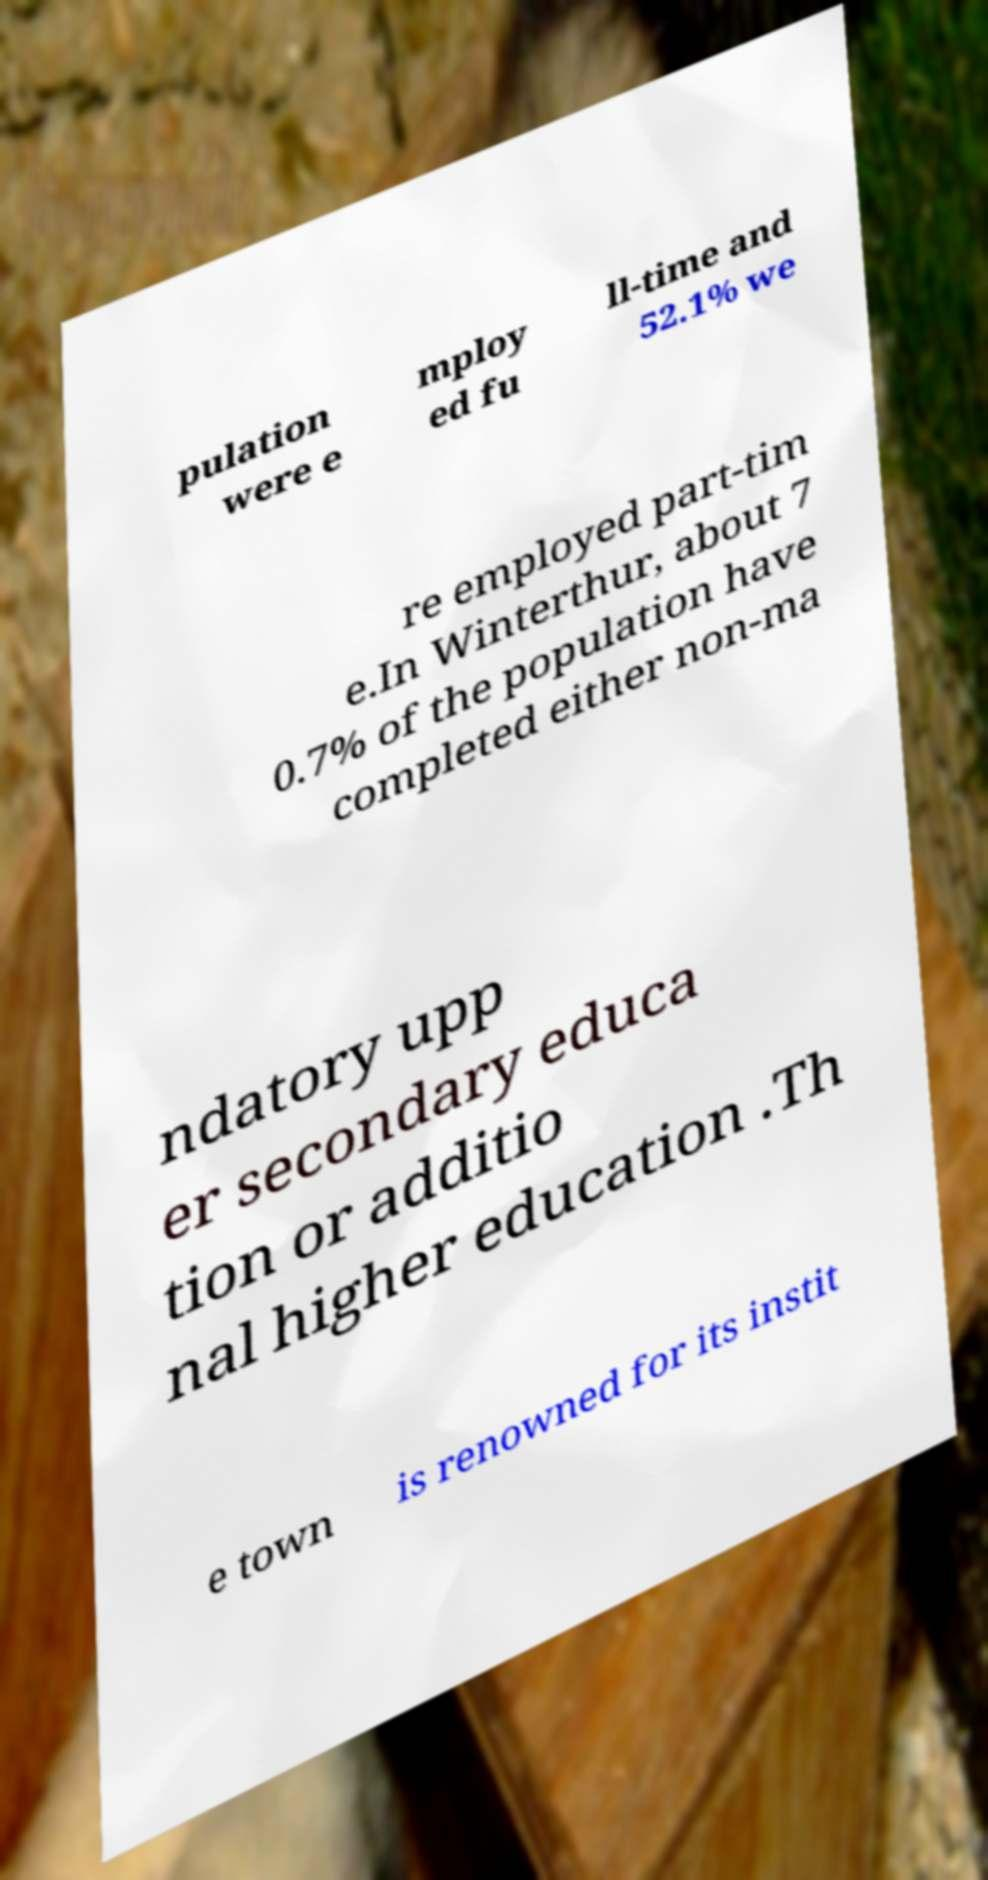For documentation purposes, I need the text within this image transcribed. Could you provide that? pulation were e mploy ed fu ll-time and 52.1% we re employed part-tim e.In Winterthur, about 7 0.7% of the population have completed either non-ma ndatory upp er secondary educa tion or additio nal higher education .Th e town is renowned for its instit 